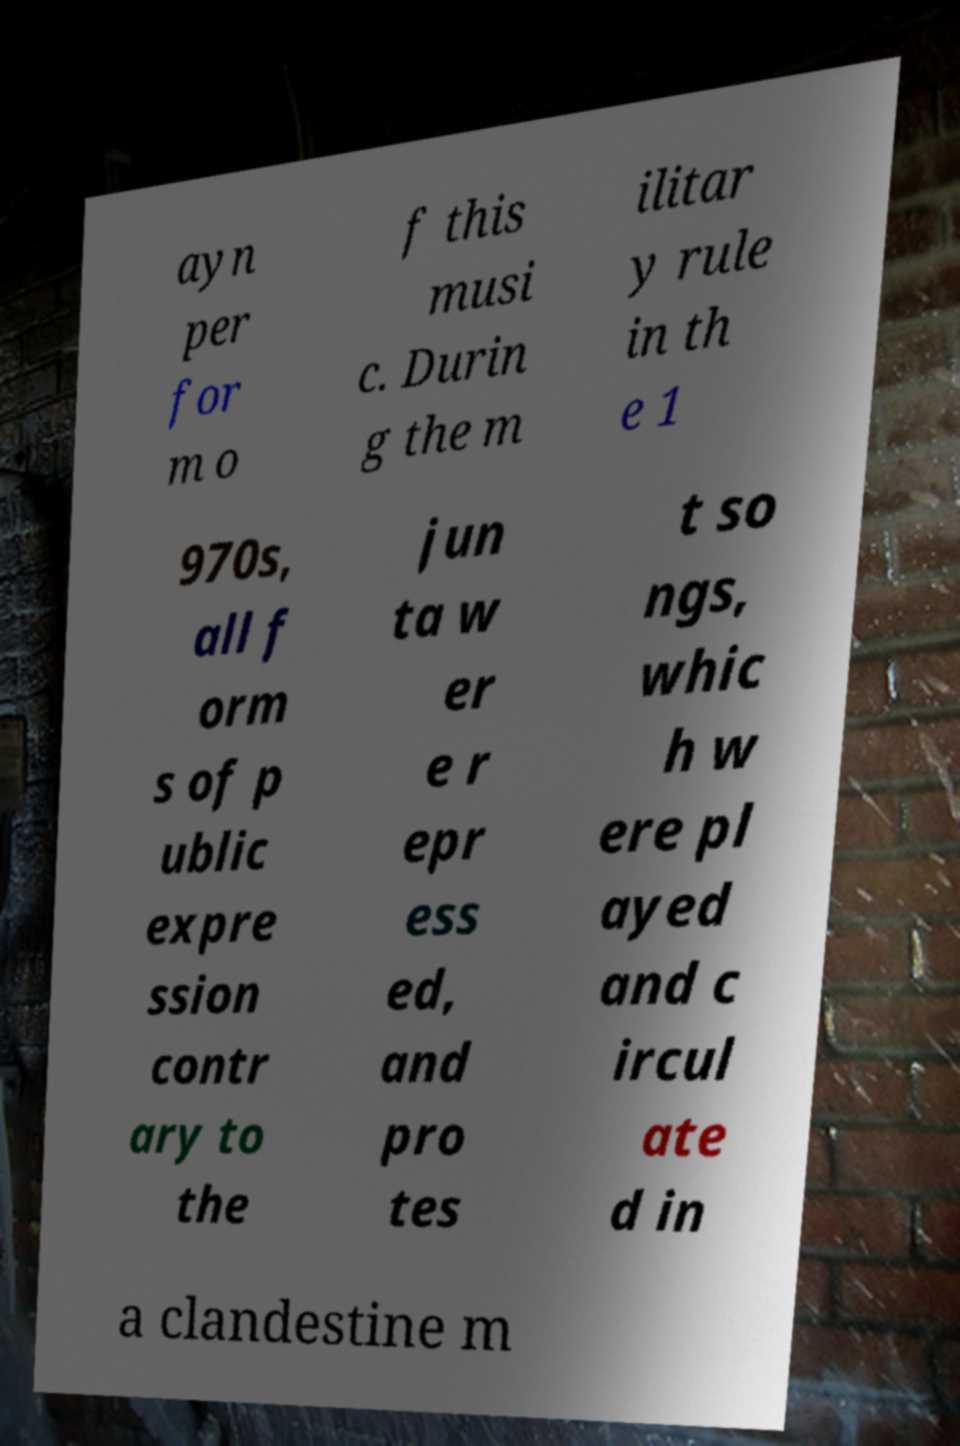Can you read and provide the text displayed in the image?This photo seems to have some interesting text. Can you extract and type it out for me? ayn per for m o f this musi c. Durin g the m ilitar y rule in th e 1 970s, all f orm s of p ublic expre ssion contr ary to the jun ta w er e r epr ess ed, and pro tes t so ngs, whic h w ere pl ayed and c ircul ate d in a clandestine m 